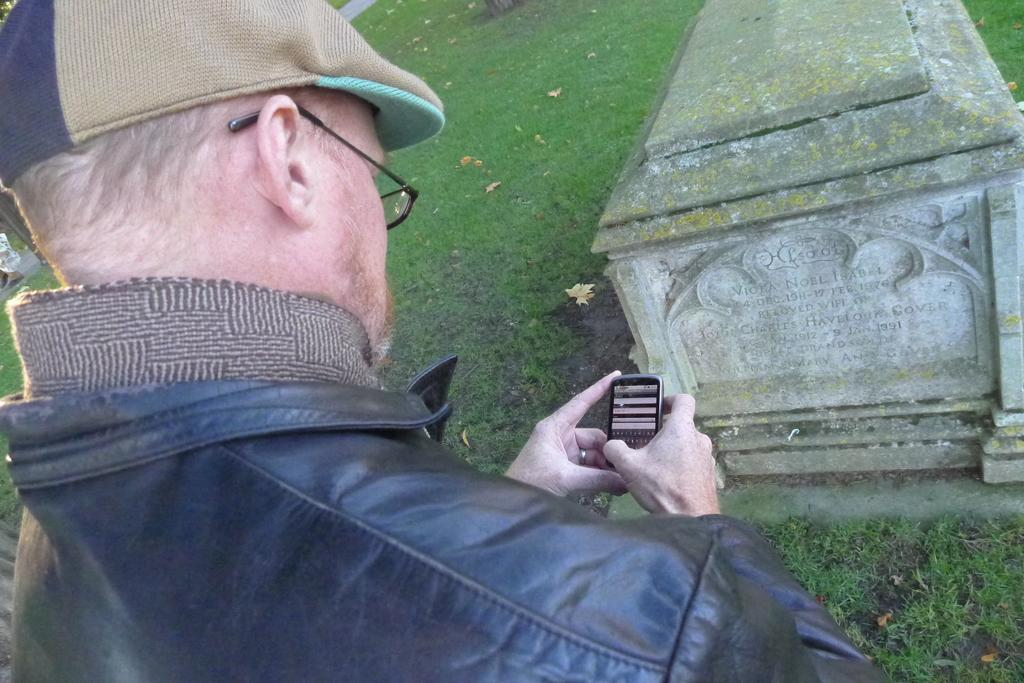What is the main subject of the image? There is a man in the image. What is the man doing in the image? The man is standing in the image. What object is the man holding in his hand? The man is holding a mobile in his hand. What type of structure can be seen in the image? There is a gravestone in the image. What type of vegetation is visible in the image? There is grass visible in the image. Where is the playground located in the image? There is no playground present in the image. What type of ball is the man playing with in the image? There is no ball present in the image, and the man is not playing with any object. 